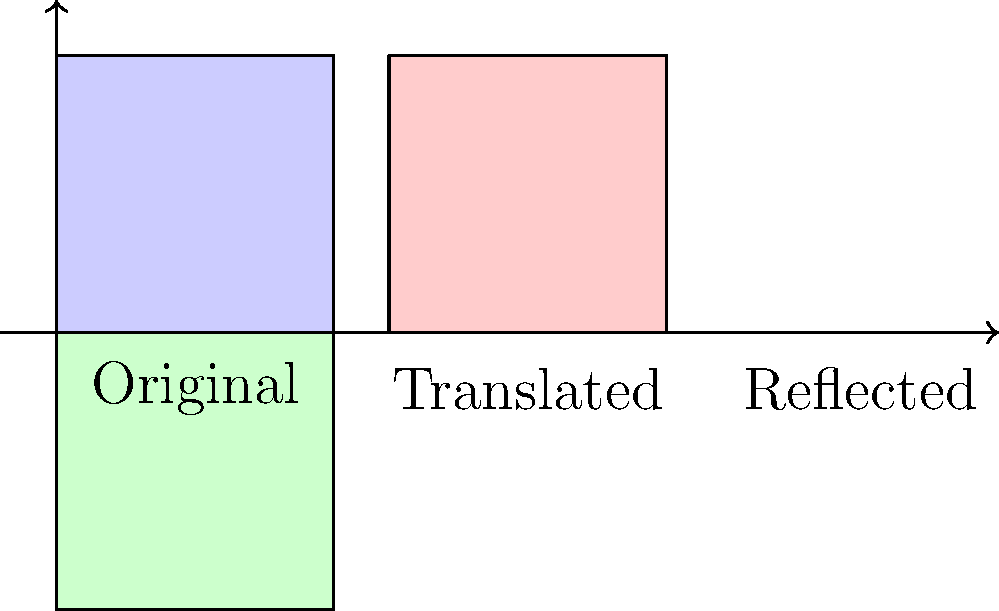In creating a repeating pattern for an animated texture, an animator uses a square shape and applies transformations. If the original square is translated 1.2 units to the right and then reflected across the vertical line x = 2.4, what is the total horizontal distance between the leftmost point of the original square and the rightmost point of the reflected square? To solve this problem, let's follow these steps:

1. Understand the initial square:
   - The original square has a width of 1 unit.
   - Its leftmost point is at x = 0.

2. Translate the square:
   - The square is moved 1.2 units to the right.
   - The leftmost point of the translated square is now at x = 1.2.
   - The rightmost point of the translated square is at x = 2.2 (1.2 + 1).

3. Reflect the square:
   - The square is reflected across the line x = 2.4.
   - This means the distance from x = 2.4 to the leftmost point of the reflected square
     is the same as the distance from x = 2.4 to the rightmost point of the translated square.
   - The distance from x = 2.4 to x = 2.2 is 0.2 units.
   - So, the leftmost point of the reflected square is at x = 2.6 (2.4 + 0.2).
   - The width of the reflected square is still 1 unit.
   - The rightmost point of the reflected square is at x = 3.6 (2.6 + 1).

4. Calculate the total horizontal distance:
   - The distance is from x = 0 (leftmost point of original) to x = 3.6 (rightmost point of reflected).
   - Total distance = 3.6 - 0 = 3.6 units.
Answer: 3.6 units 